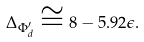<formula> <loc_0><loc_0><loc_500><loc_500>\Delta _ { \Phi ^ { \prime } _ { d } } \cong 8 - 5 . 9 2 \epsilon .</formula> 